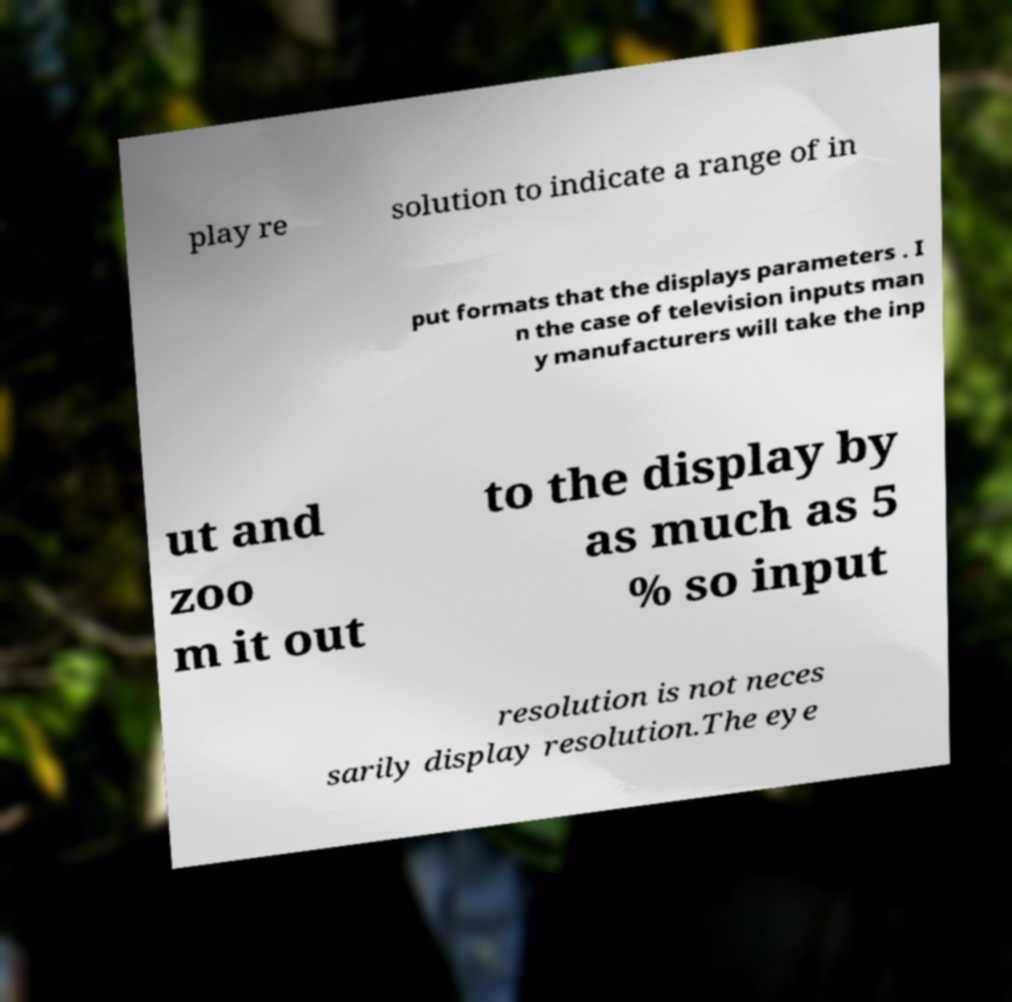Could you extract and type out the text from this image? play re solution to indicate a range of in put formats that the displays parameters . I n the case of television inputs man y manufacturers will take the inp ut and zoo m it out to the display by as much as 5 % so input resolution is not neces sarily display resolution.The eye 